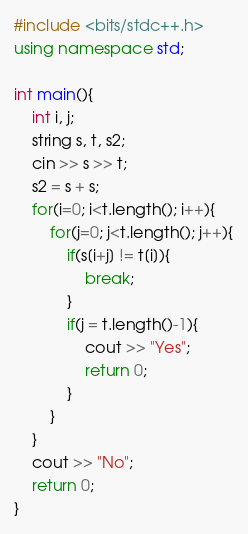<code> <loc_0><loc_0><loc_500><loc_500><_C++_>#include <bits/stdc++.h>
using namespace std;

int main(){
    int i, j;
    string s, t, s2;
    cin >> s >> t;
    s2 = s + s;
    for(i=0; i<t.length(); i++){
        for(j=0; j<t.length(); j++){
            if(s[i+j] != t[i]){
                break;
            }
            if(j = t.length()-1){
                cout >> "Yes";
                return 0;
            }
        }
    }
    cout >> "No";
    return 0;
}</code> 